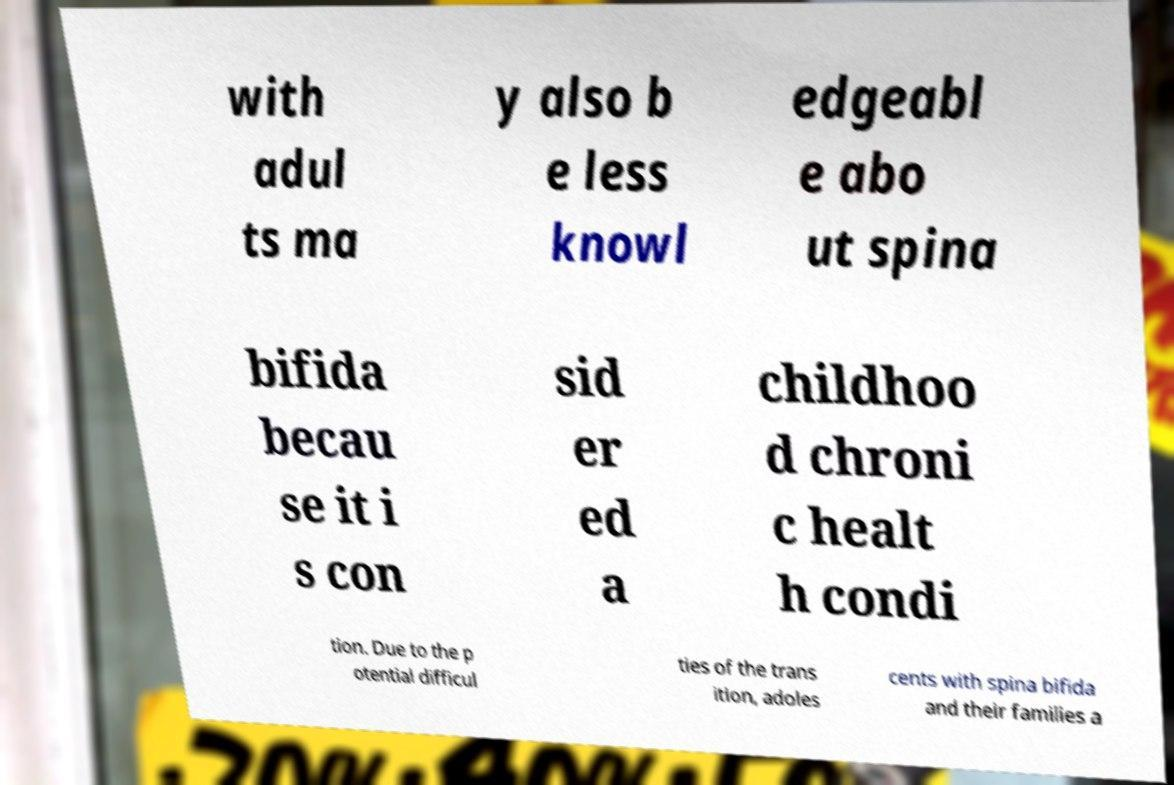I need the written content from this picture converted into text. Can you do that? with adul ts ma y also b e less knowl edgeabl e abo ut spina bifida becau se it i s con sid er ed a childhoo d chroni c healt h condi tion. Due to the p otential difficul ties of the trans ition, adoles cents with spina bifida and their families a 